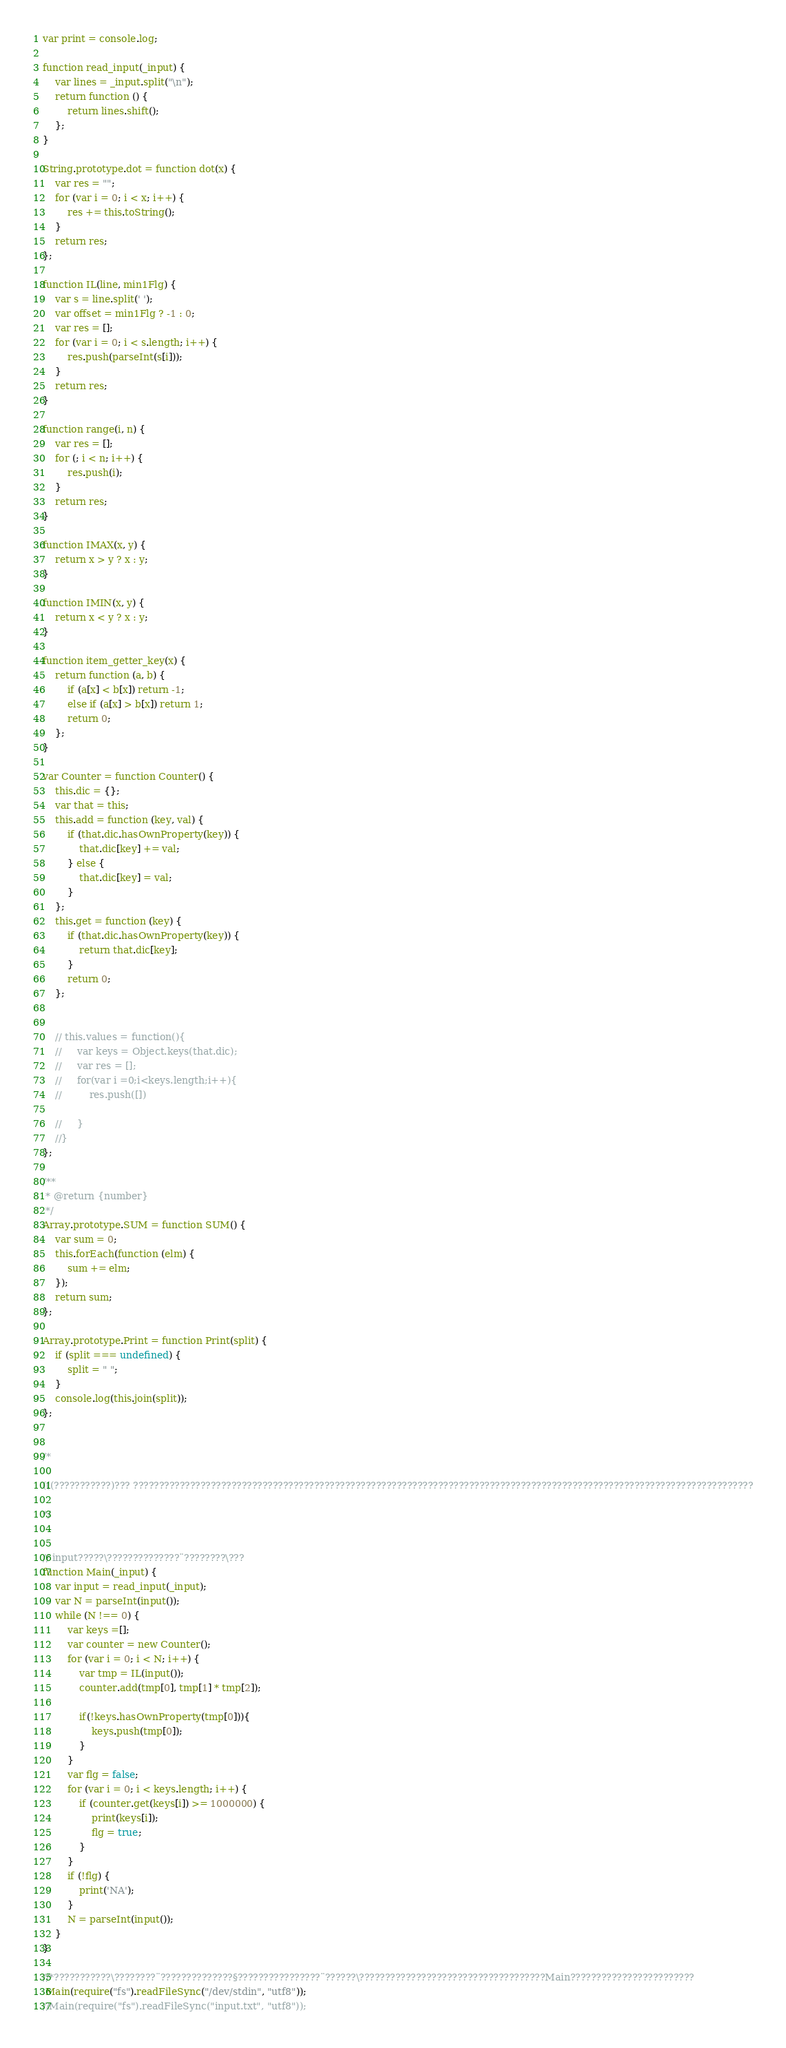<code> <loc_0><loc_0><loc_500><loc_500><_JavaScript_>var print = console.log;

function read_input(_input) {
    var lines = _input.split("\n");
    return function () {
        return lines.shift();
    };
}

String.prototype.dot = function dot(x) {
    var res = "";
    for (var i = 0; i < x; i++) {
        res += this.toString();
    }
    return res;
};

function IL(line, min1Flg) {
    var s = line.split(' ');
    var offset = min1Flg ? -1 : 0;
    var res = [];
    for (var i = 0; i < s.length; i++) {
        res.push(parseInt(s[i]));
    }
    return res;
}

function range(i, n) {
    var res = [];
    for (; i < n; i++) {
        res.push(i);
    }
    return res;
}

function IMAX(x, y) {
    return x > y ? x : y;
}

function IMIN(x, y) {
    return x < y ? x : y;
}

function item_getter_key(x) {
    return function (a, b) {
        if (a[x] < b[x]) return -1;
        else if (a[x] > b[x]) return 1;
        return 0;
    };
}

var Counter = function Counter() {
    this.dic = {};
    var that = this;
    this.add = function (key, val) {
        if (that.dic.hasOwnProperty(key)) {
            that.dic[key] += val;
        } else {
            that.dic[key] = val;
        }
    };
    this.get = function (key) {
        if (that.dic.hasOwnProperty(key)) {
            return that.dic[key];
        }
        return 0;
    };


    // this.values = function(){
    //     var keys = Object.keys(that.dic);
    //     var res = [];
    //     for(var i =0;i<keys.length;i++){
    //         res.push([])

    //     }
    //}
};

/**
 * @return {number}
 */
Array.prototype.SUM = function SUM() {
    var sum = 0;
    this.forEach(function (elm) {
        sum += elm;
    });
    return sum;
};

Array.prototype.Print = function Print(split) {
    if (split === undefined) {
        split = " ";
    }
    console.log(this.join(split));
};


/*

(((???????????)??? ????????????????????????????????????????????????????????????????????????????????????????????????????????????????????????

*/


// input?????\??????????????¨????????\???
function Main(_input) {
    var input = read_input(_input);
    var N = parseInt(input());
    while (N !== 0) {
        var keys =[];
        var counter = new Counter();
        for (var i = 0; i < N; i++) {
            var tmp = IL(input());
            counter.add(tmp[0], tmp[1] * tmp[2]);

            if(!keys.hasOwnProperty(tmp[0])){
                keys.push(tmp[0]);
            }
        }
        var flg = false;
        for (var i = 0; i < keys.length; i++) {
            if (counter.get(keys[i]) >= 1000000) {
                print(keys[i]);
                flg = true;
            }
        }
        if (!flg) {
            print('NA');
        }
        N = parseInt(input());
    }
}

//*???????????\????????¨??????????????§????????????????¨??????\????????????????????????????????????Main????????????????????????
 Main(require("fs").readFileSync("/dev/stdin", "utf8"));
//Main(require("fs").readFileSync("input.txt", "utf8"));</code> 